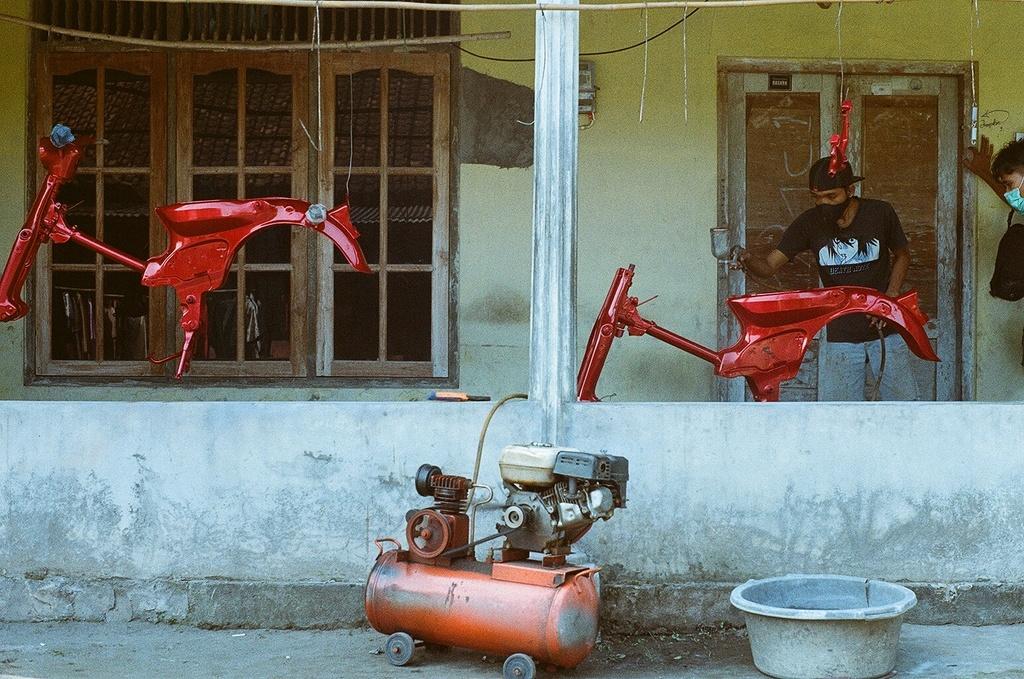Could you give a brief overview of what you see in this image? In this image, we can see a man standing and he is painting a bike, there is a compressor and in the background we can see a wall and there is a door and we can see some windows. 